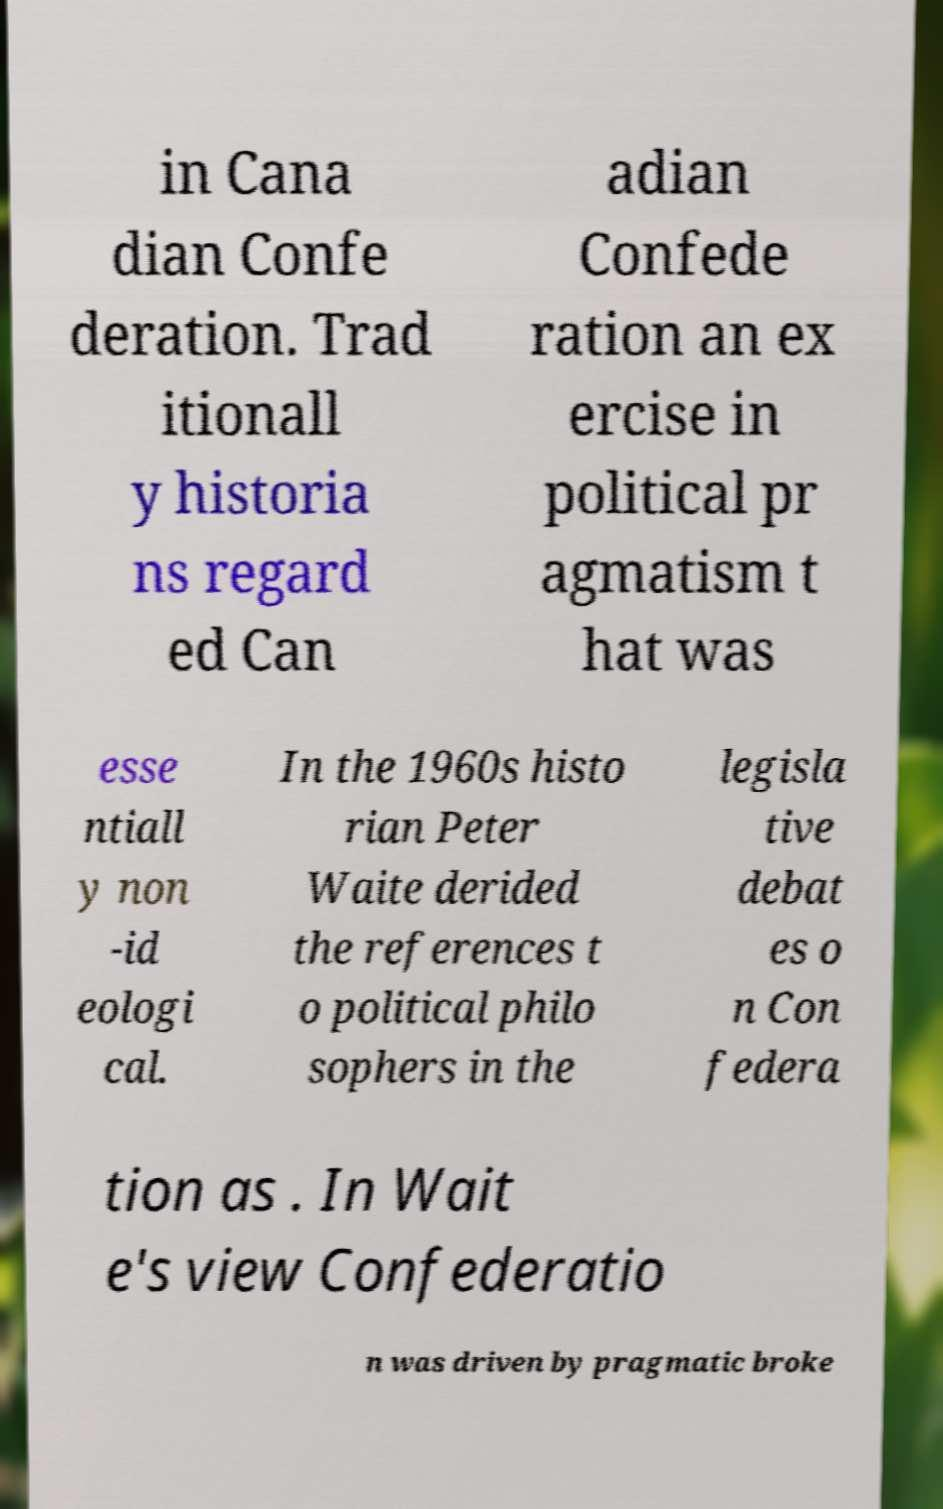What messages or text are displayed in this image? I need them in a readable, typed format. in Cana dian Confe deration. Trad itionall y historia ns regard ed Can adian Confede ration an ex ercise in political pr agmatism t hat was esse ntiall y non -id eologi cal. In the 1960s histo rian Peter Waite derided the references t o political philo sophers in the legisla tive debat es o n Con federa tion as . In Wait e's view Confederatio n was driven by pragmatic broke 